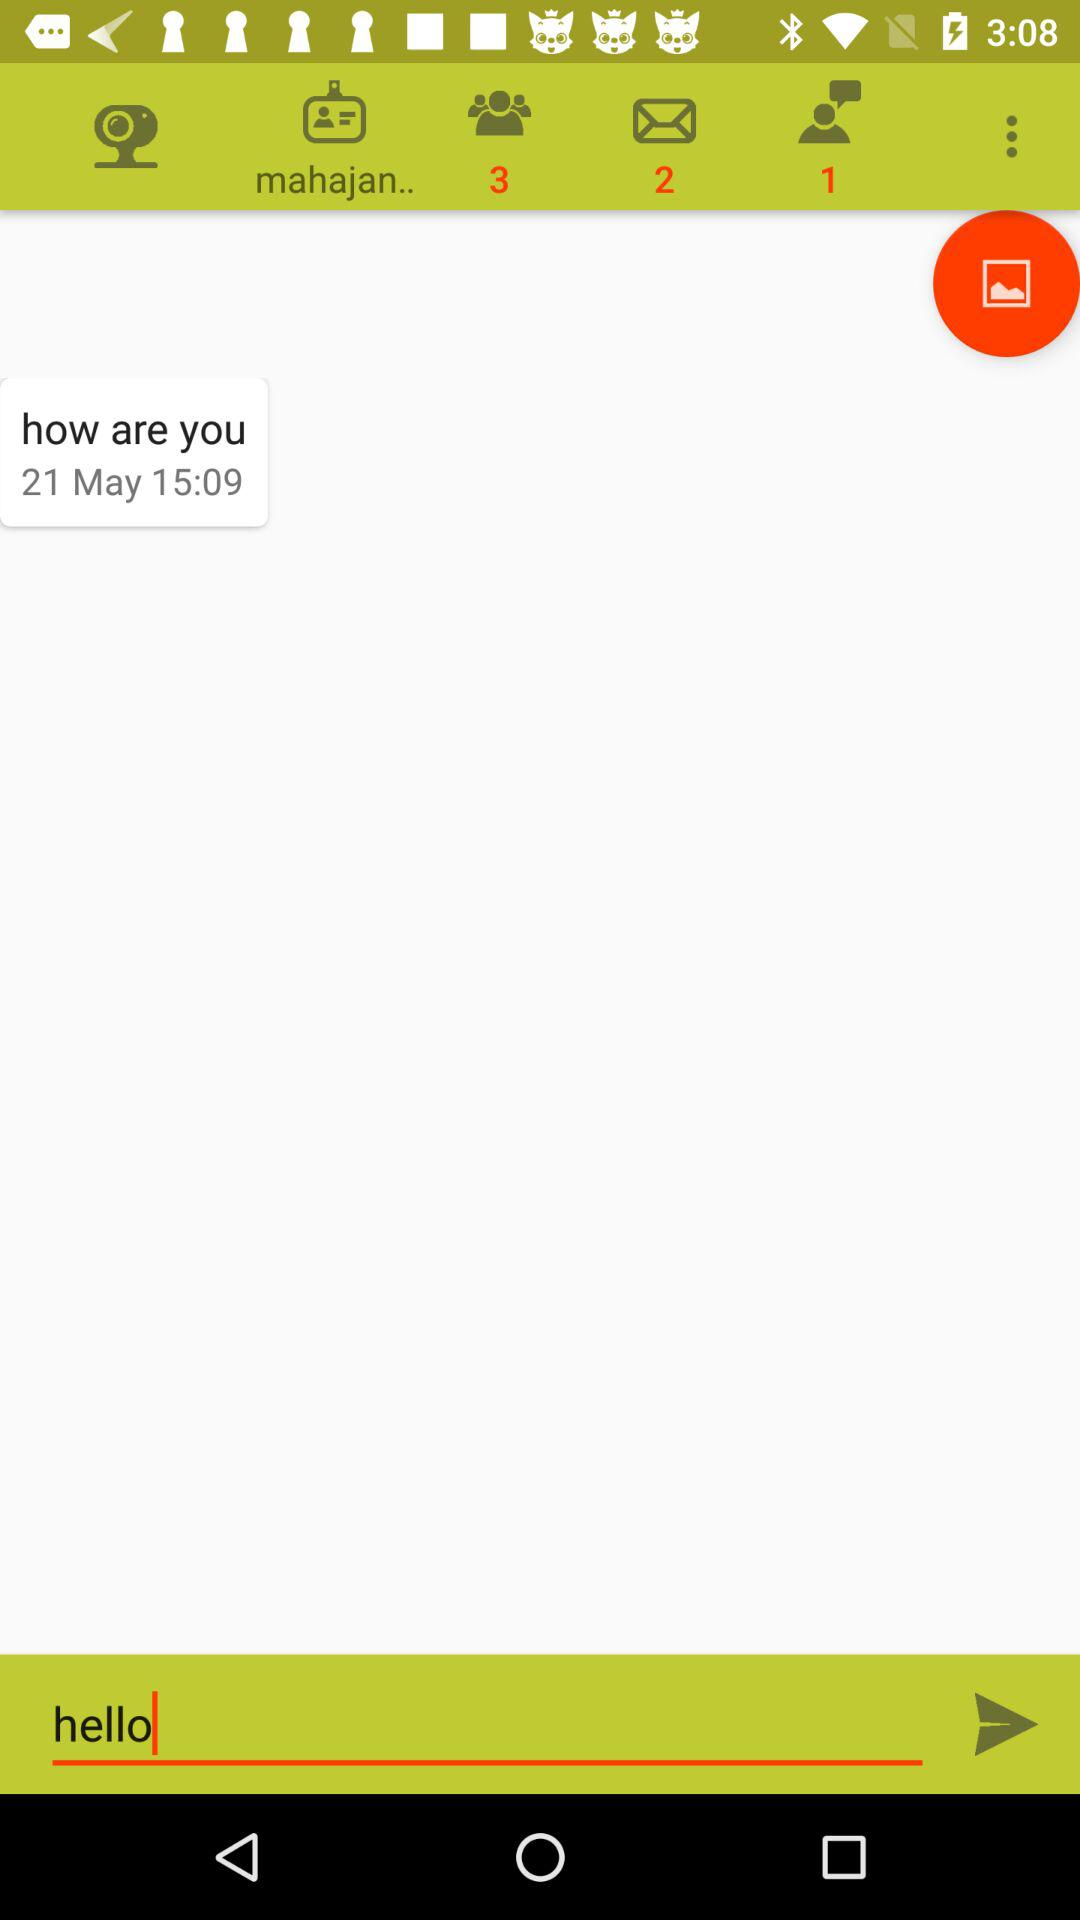How many more people are there than chats?
Answer the question using a single word or phrase. 2 